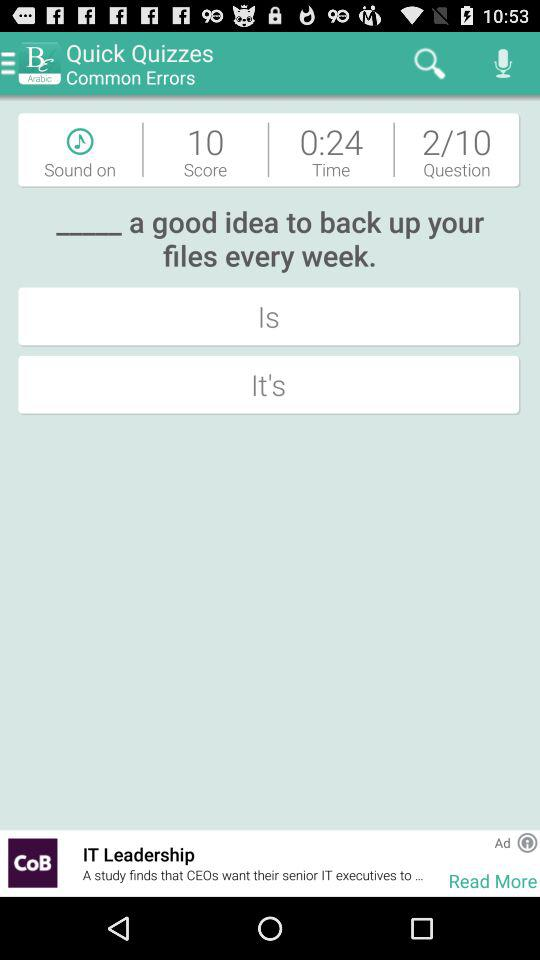How many questions in total are there? There are 10 questions. 